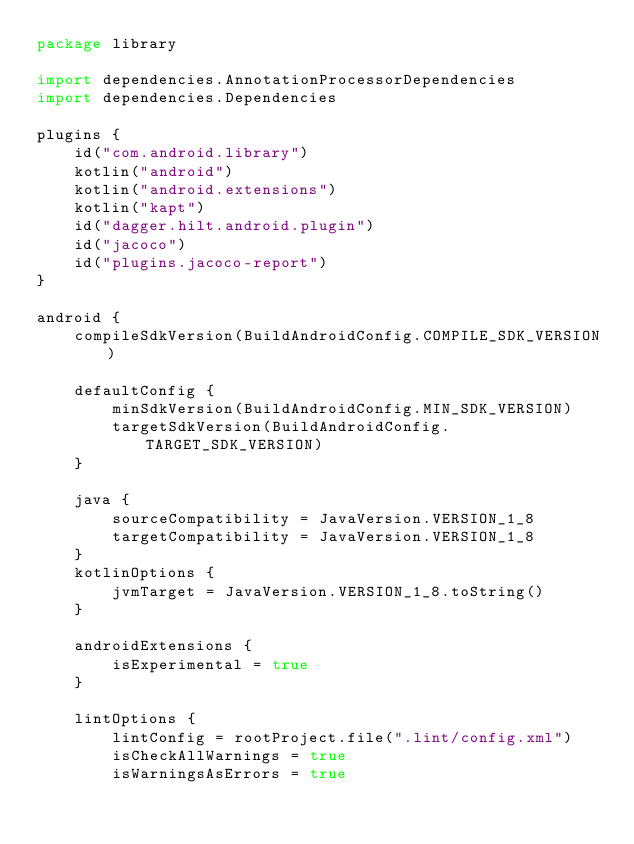Convert code to text. <code><loc_0><loc_0><loc_500><loc_500><_Kotlin_>package library

import dependencies.AnnotationProcessorDependencies
import dependencies.Dependencies

plugins {
    id("com.android.library")
    kotlin("android")
    kotlin("android.extensions")
    kotlin("kapt")
    id("dagger.hilt.android.plugin")
    id("jacoco")
    id("plugins.jacoco-report")
}

android {
    compileSdkVersion(BuildAndroidConfig.COMPILE_SDK_VERSION)

    defaultConfig {
        minSdkVersion(BuildAndroidConfig.MIN_SDK_VERSION)
        targetSdkVersion(BuildAndroidConfig.TARGET_SDK_VERSION)
    }

    java {
        sourceCompatibility = JavaVersion.VERSION_1_8
        targetCompatibility = JavaVersion.VERSION_1_8
    }
    kotlinOptions {
        jvmTarget = JavaVersion.VERSION_1_8.toString()
    }

    androidExtensions {
        isExperimental = true
    }

    lintOptions {
        lintConfig = rootProject.file(".lint/config.xml")
        isCheckAllWarnings = true
        isWarningsAsErrors = true</code> 